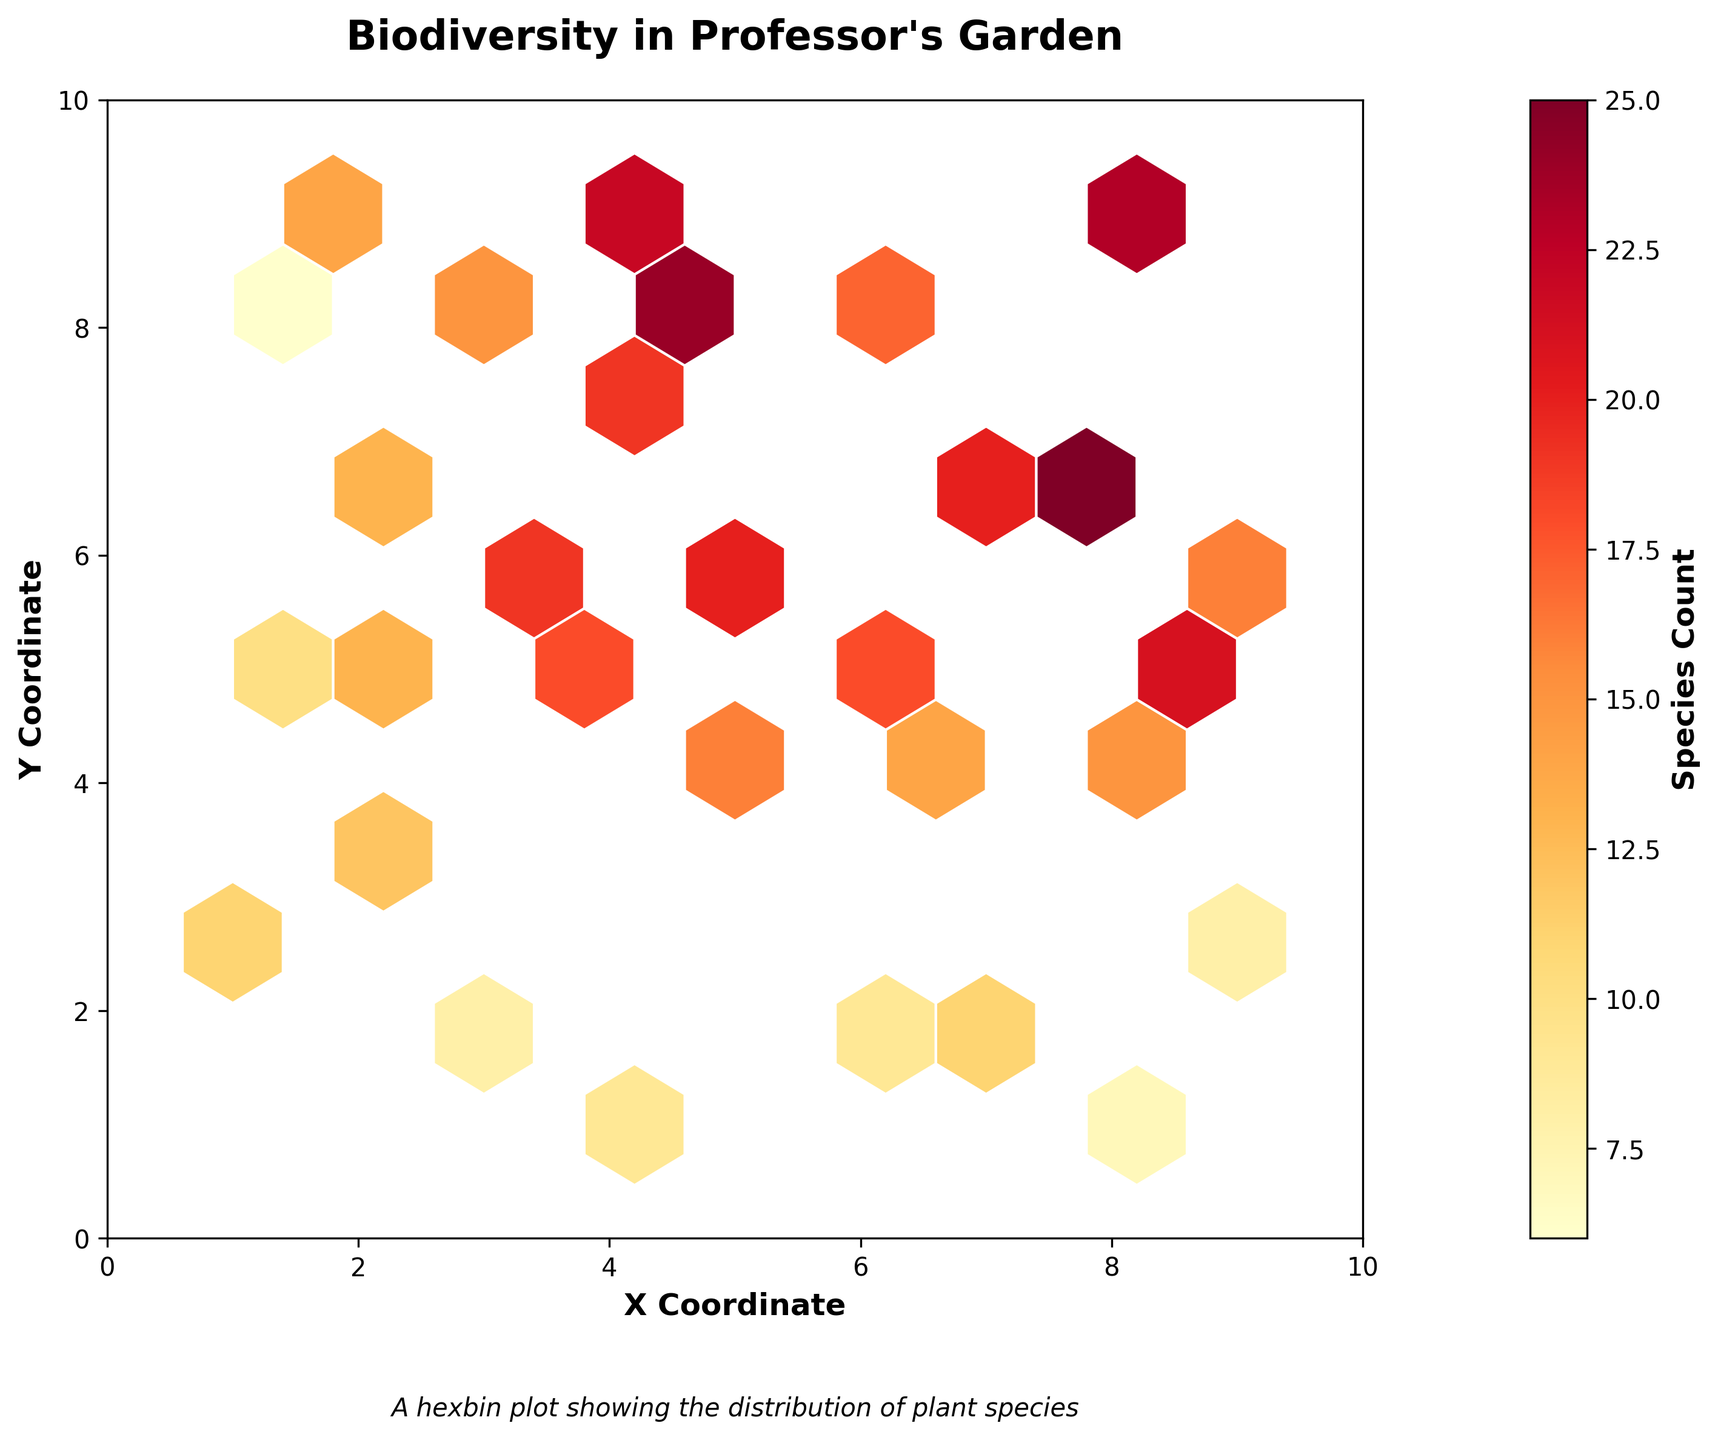What is the title of the plot? The plot's title is usually found at the top of the figure. It summarizes the main topic or data representation of the plot.
Answer: Biodiversity in Professor's Garden What do the x and y axes represent in the plot? The x-axis represents the horizontal coordinates (X Coordinate) and the y-axis represents the vertical coordinates (Y Coordinate) in the garden. These axes help to locate the specific areas where biodiversity measures were taken.
Answer: X Coordinate and Y Coordinate Which color is used to represent the highest species count? In the color intensity scale (color bar), the lightest color represents the lowest count and the darkest color represents the highest count. Observing the range of colors, the darkest color (deep red) corresponds to the highest species count.
Answer: Deep Red What is the color intensity indicating in the plot? The color intensity on a hexbin plot typically shows the density or count of data points within each hexagonal bin. Here, the color intensity indicates the biodiversity, with darker colors representing higher species counts.
Answer: Biodiversity/Species Count Based on the plot, which area in the garden has the highest species count? By observing the hexagons with the darkest color (deep red), we can identify the area with the highest species count. Look for the coordinates of this darkest hexagon.
Answer: Around coordinates (8, 9) Which area has the lowest species count? The lightest color on the hexbin plot indicates the lowest species count. By locating the lightest hexagons, we can determine the coordinates of the area with the lowest count.
Answer: Around coordinates (8, 1) Is the distribution of species more dense in the lower or upper half of the garden? By dividing the garden into the lower half (y ≤ 5) and the upper half (y > 5), we compare the color intensity of hexagons in both halves. Since the upper half contains more darker colors, it indicates a denser distribution.
Answer: Upper half of the garden How many distinct species count regions can you observe in the colorbar? Observing the range of color variations from the lightest to the darkest color in the colorbar, we can count the distinct regions representing different ranges of species count.
Answer: Approximately 10 distinct regions What average species count can be inferred from the central region of the garden (5, 5)? To determine the average species count in the central region, we look at the hexagons around the coordinates (5, 5) and estimate their color intensity ranges to infer average biodiversity.
Answer: Around 18-20 Compare the species count at coordinates (4, 9) and (2, 9). Which location has a higher biodiversity? By locating the hexagons at these coordinates and comparing their color intensities on the plot, we can see that the hexagon at (4, 9) is darker compared to (2, 9), indicating a higher species count.
Answer: Coordinates (4, 9) 